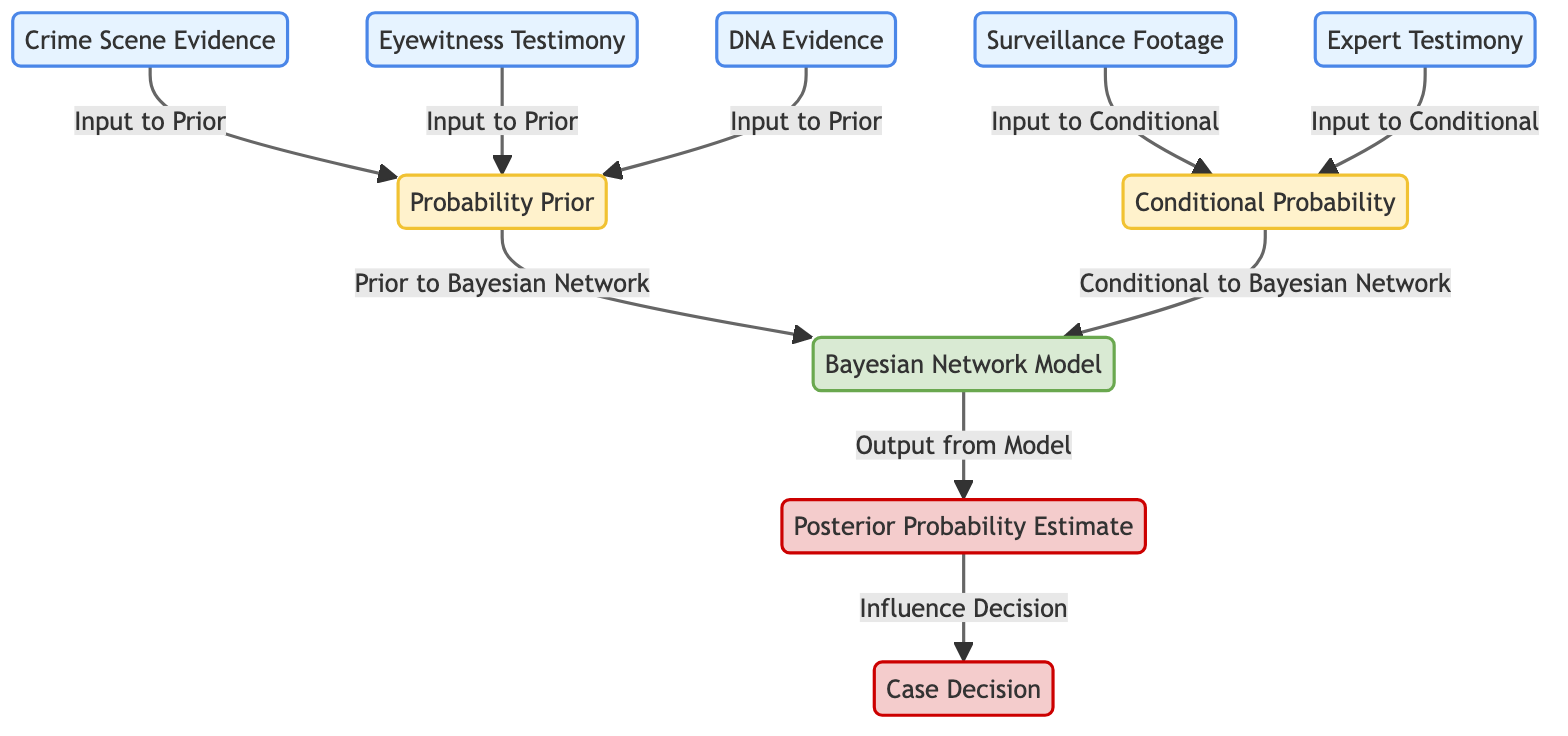What are the inputs to the prior probability node? The inputs to the prior probability node (node 6) are the "Crime Scene Evidence," "Eyewitness Testimony," and "DNA Evidence," as indicated by the arrows leading into node 6 from these weights.
Answer: Crime Scene Evidence, Eyewitness Testimony, DNA Evidence How many output nodes are present in the diagram? The diagram features two output nodes: "Posterior Probability Estimate" (node 9) and "Case Decision" (node 10), which are the final results of the analysis performed by the Bayesian Network Model.
Answer: 2 What type of evidence is combined in the conditional probability node? The conditional probability node (node 7) incorporates the "Surveillance Footage" and "Expert Testimony," as shown by the arrows pointing towards node 7.
Answer: Surveillance Footage, Expert Testimony Which node directly informs the case decision? The node that directly informs the case decision is the "Posterior Probability Estimate" (node 9), which is connected to the "Case Decision" (node 10) through an arrow.
Answer: Posterior Probability Estimate Which method is represented by node 8? Node 8 represents the "Bayesian Network Model," which combines inputs from both prior and conditional probabilities to compute the posterior probability estimates.
Answer: Bayesian Network Model What is the relationship between the Bayesian Network Model and the posterior probability? The relationship is such that the Bayesian Network Model (node 8) produces the Posterior Probability Estimate (node 9) as its output, which is influenced by the probabilities calculated in the model.
Answer: Output from Model What is the function of the probability prior in this diagram? The probability prior (node 6) serves to aggregate inputs from various evidence types (Crime Scene Evidence, Eyewitness Testimony, DNA Evidence) to create a baseline probability before further analysis with the Bayesian Network Model.
Answer: Baseline probability How many nodes are mapped to conditional probabilities in this diagram? There are two input nodes mapped to conditional probabilities: "Surveillance Footage" and "Expert Testimony," which are processed in the conditional probability node (node 7).
Answer: 2 How does the evidence influence the case decision? The evidence influences the case decision by first being combined into posterior probability estimates within the Bayesian Network Model. These estimates, once calculated, shape the final decision made in the case, showing a direct path from analysis to conclusion.
Answer: Directly influences through posterior estimates 